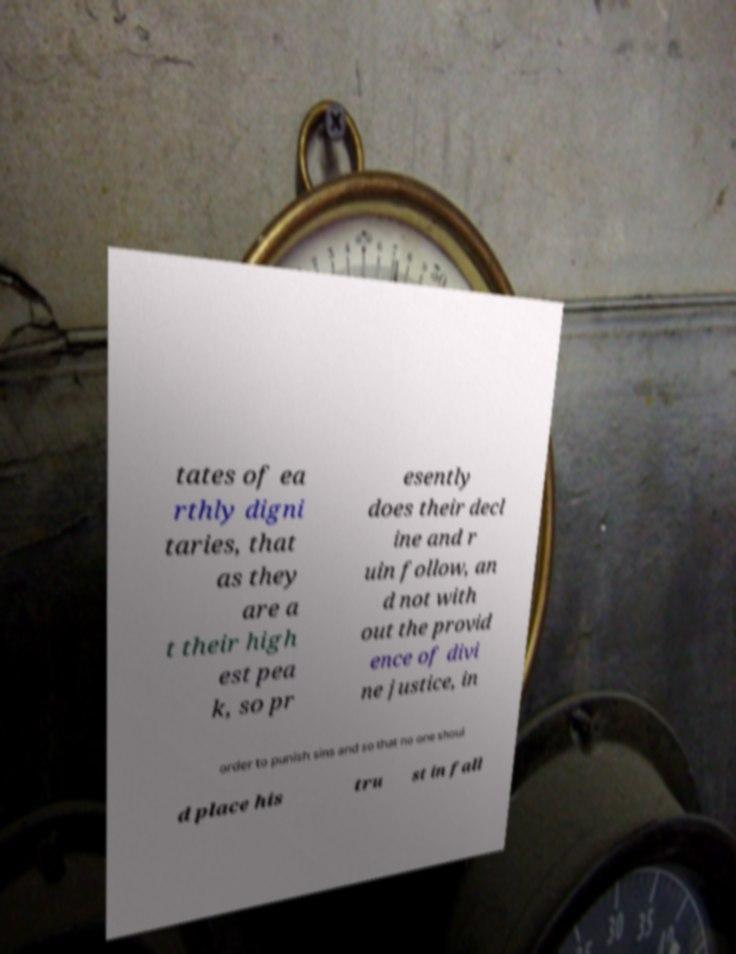What messages or text are displayed in this image? I need them in a readable, typed format. tates of ea rthly digni taries, that as they are a t their high est pea k, so pr esently does their decl ine and r uin follow, an d not with out the provid ence of divi ne justice, in order to punish sins and so that no one shoul d place his tru st in fall 